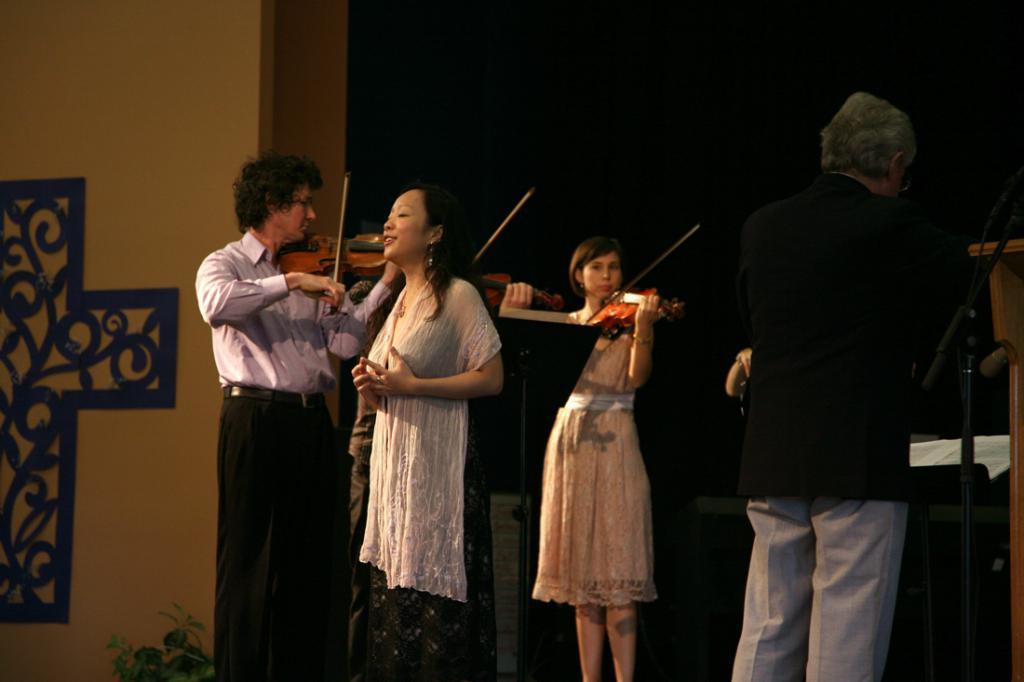Describe this image in one or two sentences. In this image there are four persons who are standing. On the right side one person who is standing, on the left side there is another person who is standing and he is playing a violin. On the middle of the image there are two girls who are standing. In the left side of the image there is one woman who is standing, it seems that she is singing. On the left side there is one wall on the bottom of the left corner there is one plant. 